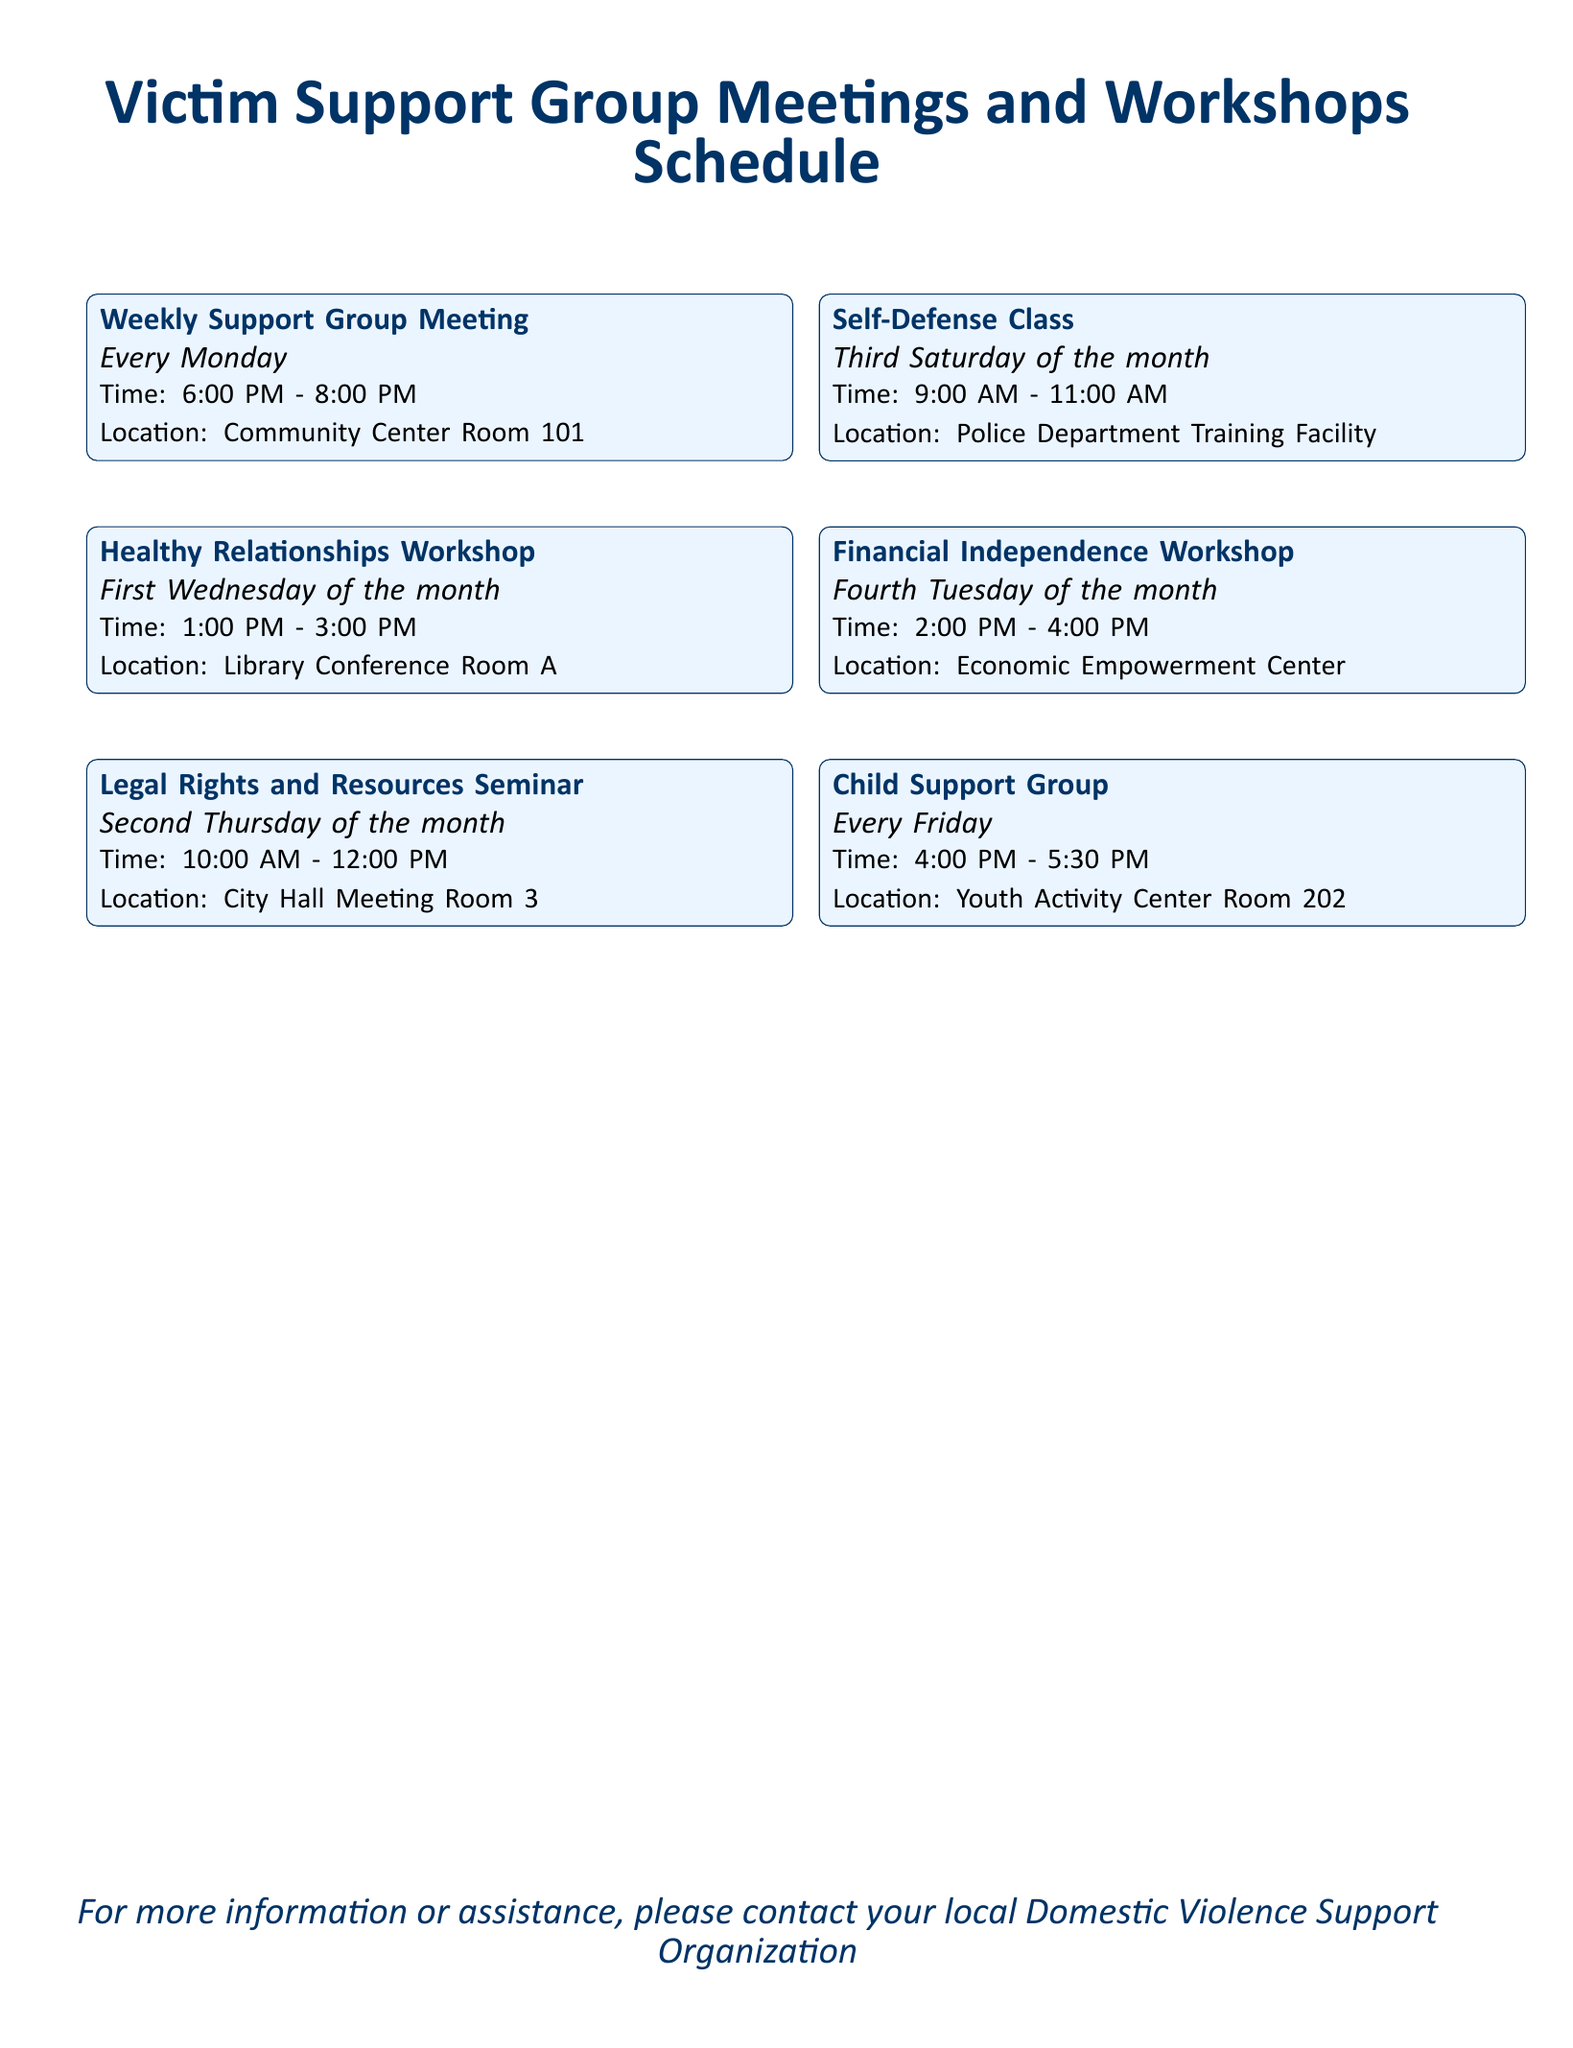What day is the Healthy Relationships Workshop scheduled? The Healthy Relationships Workshop is held on the first Wednesday of the month.
Answer: First Wednesday What time does the Weekly Support Group Meeting start? The Weekly Support Group Meeting begins at 6:00 PM.
Answer: 6:00 PM Where is the Legal Rights and Resources Seminar located? The Legal Rights and Resources Seminar takes place in City Hall Meeting Room 3.
Answer: City Hall Meeting Room 3 How often is the Self-Defense Class held? The Self-Defense Class occurs on the third Saturday of the month.
Answer: Third Saturday What is the duration of the Child Support Group? The Child Support Group runs for an hour and a half, from 4:00 PM to 5:30 PM.
Answer: 1.5 hours Which workshop focuses on financial independence? The Financial Independence Workshop is aimed at enhancing financial self-sufficiency.
Answer: Financial Independence Workshop What is the location of the Community Center Room 101? Community Center Room 101 is where the Weekly Support Group Meeting is held.
Answer: Community Center Room 101 How many events are scheduled on a monthly basis? There are six distinct events scheduled every month.
Answer: Six events 